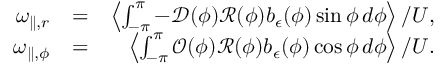Convert formula to latex. <formula><loc_0><loc_0><loc_500><loc_500>\begin{array} { r l r } { \omega _ { \| , r } } & { = } & { \left \langle \int _ { - \pi } ^ { \pi } - \mathcal { D } ( \phi ) \mathcal { R } ( \phi ) b _ { \epsilon } ( \phi ) \sin \phi \, d \phi \right \rangle / U , } \\ { \omega _ { \| , \phi } } & { = } & { \left \langle \int _ { - \pi } ^ { \pi } \mathcal { O } ( \phi ) \mathcal { R } ( \phi ) b _ { \epsilon } ( \phi ) \cos \phi \, d \phi \right \rangle / U . } \end{array}</formula> 